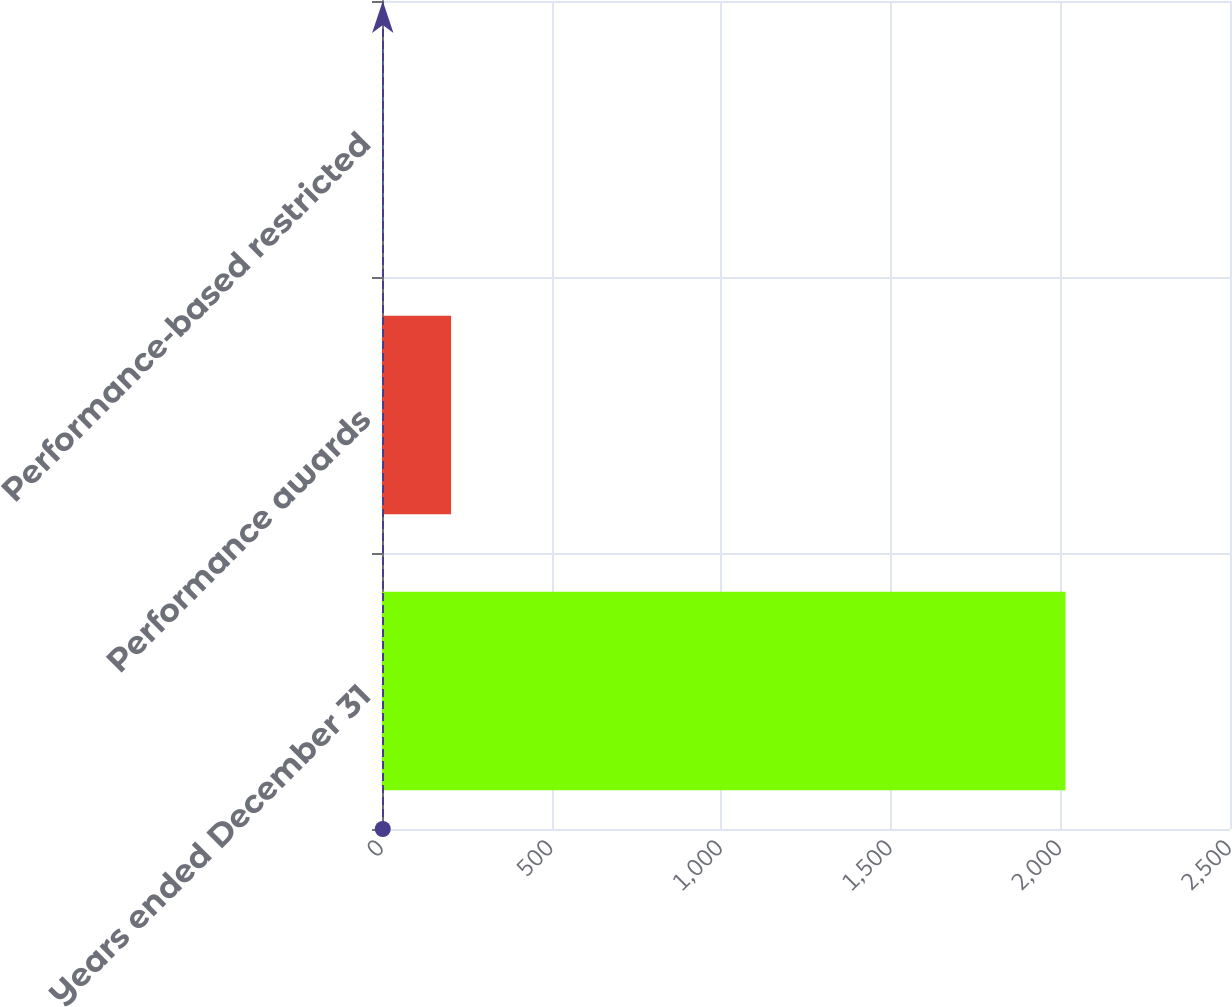<chart> <loc_0><loc_0><loc_500><loc_500><bar_chart><fcel>Years ended December 31<fcel>Performance awards<fcel>Performance-based restricted<nl><fcel>2015<fcel>203.57<fcel>2.3<nl></chart> 